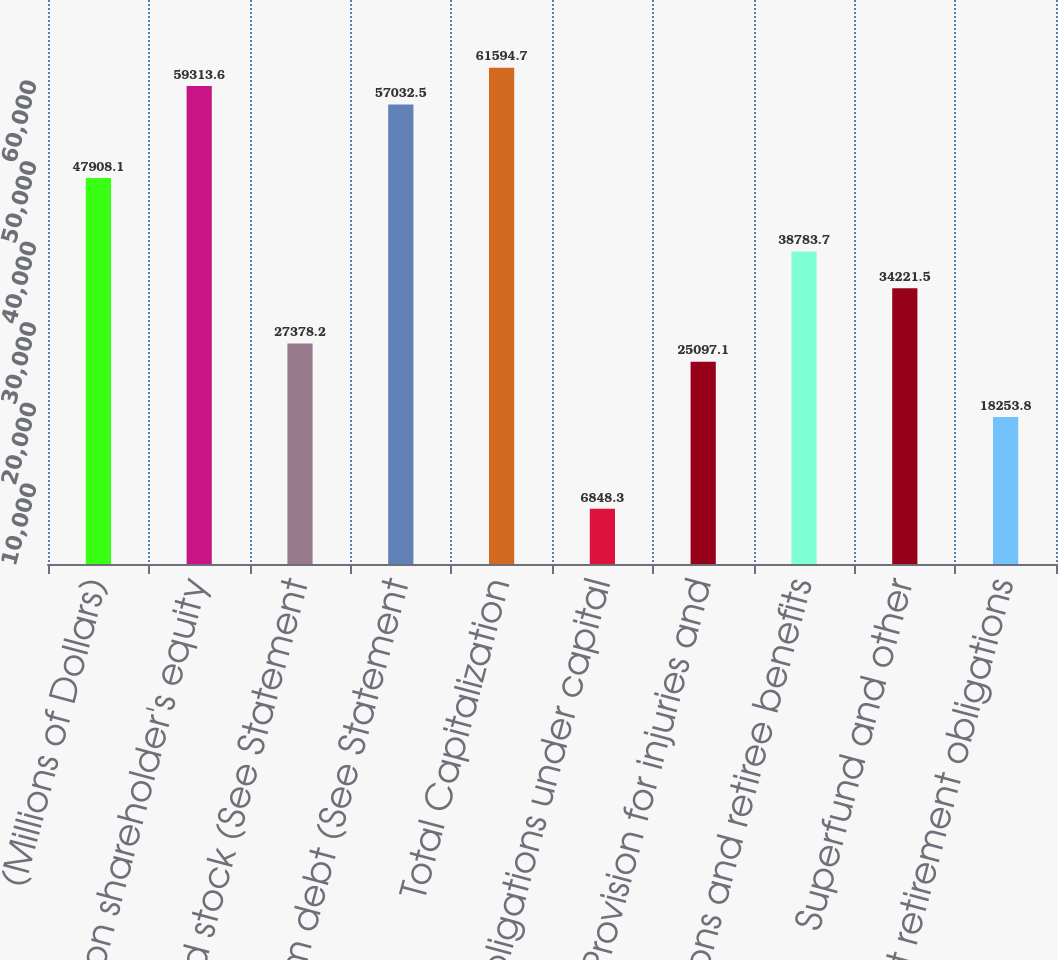<chart> <loc_0><loc_0><loc_500><loc_500><bar_chart><fcel>(Millions of Dollars)<fcel>Common shareholder's equity<fcel>Preferred stock (See Statement<fcel>Long-term debt (See Statement<fcel>Total Capitalization<fcel>Obligations under capital<fcel>Provision for injuries and<fcel>Pensions and retiree benefits<fcel>Superfund and other<fcel>Asset retirement obligations<nl><fcel>47908.1<fcel>59313.6<fcel>27378.2<fcel>57032.5<fcel>61594.7<fcel>6848.3<fcel>25097.1<fcel>38783.7<fcel>34221.5<fcel>18253.8<nl></chart> 